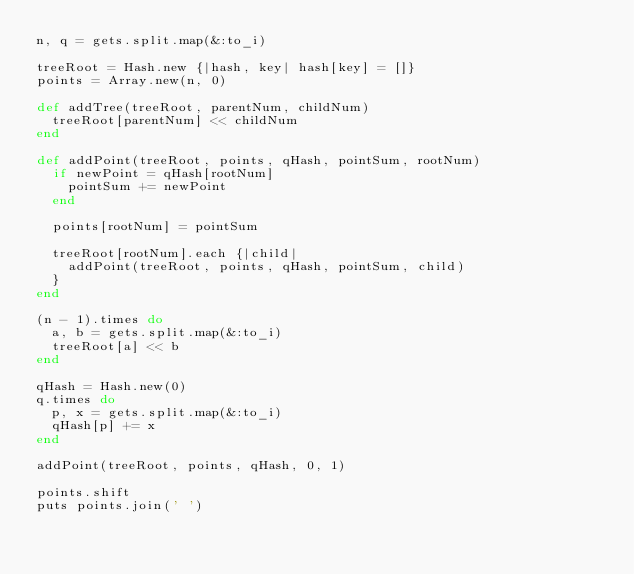<code> <loc_0><loc_0><loc_500><loc_500><_Ruby_>n, q = gets.split.map(&:to_i)

treeRoot = Hash.new {|hash, key| hash[key] = []}
points = Array.new(n, 0)

def addTree(treeRoot, parentNum, childNum)
  treeRoot[parentNum] << childNum
end

def addPoint(treeRoot, points, qHash, pointSum, rootNum)
  if newPoint = qHash[rootNum]
    pointSum += newPoint
  end

  points[rootNum] = pointSum

  treeRoot[rootNum].each {|child|
    addPoint(treeRoot, points, qHash, pointSum, child)
  }
end

(n - 1).times do
  a, b = gets.split.map(&:to_i)
  treeRoot[a] << b
end

qHash = Hash.new(0)
q.times do
  p, x = gets.split.map(&:to_i)
  qHash[p] += x
end

addPoint(treeRoot, points, qHash, 0, 1)

points.shift
puts points.join(' ')
</code> 